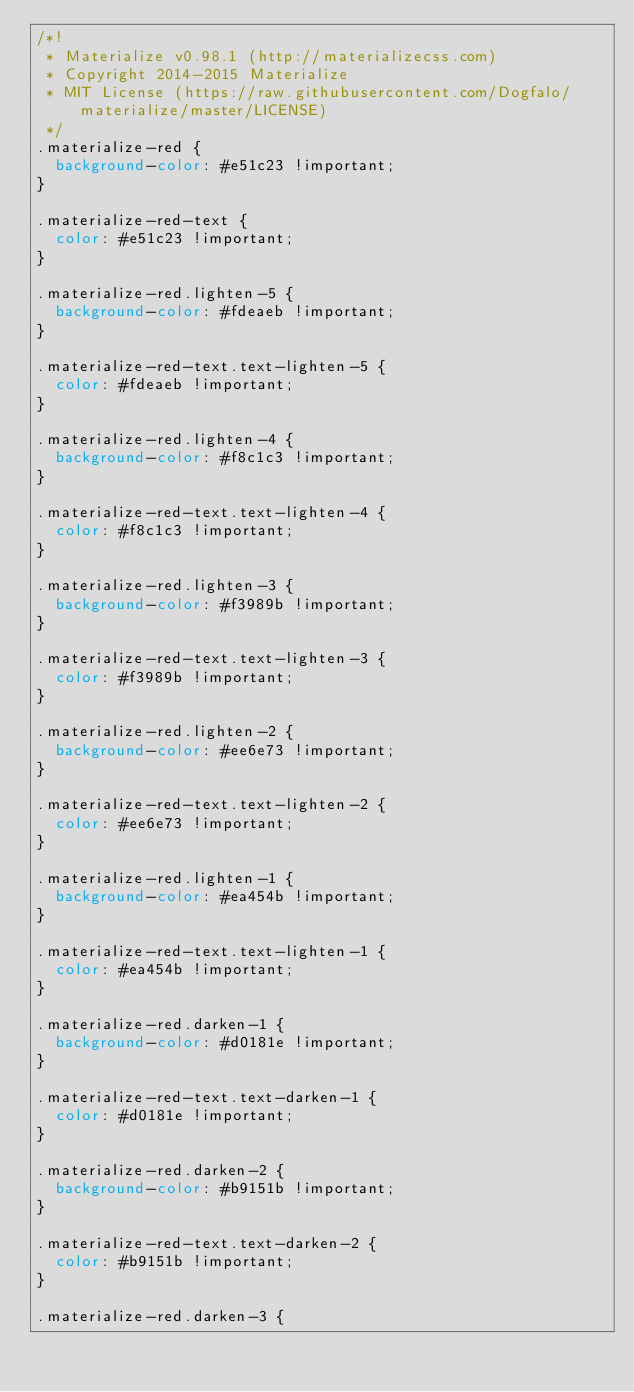Convert code to text. <code><loc_0><loc_0><loc_500><loc_500><_CSS_>/*!
 * Materialize v0.98.1 (http://materializecss.com)
 * Copyright 2014-2015 Materialize
 * MIT License (https://raw.githubusercontent.com/Dogfalo/materialize/master/LICENSE)
 */
.materialize-red {
  background-color: #e51c23 !important;
}

.materialize-red-text {
  color: #e51c23 !important;
}

.materialize-red.lighten-5 {
  background-color: #fdeaeb !important;
}

.materialize-red-text.text-lighten-5 {
  color: #fdeaeb !important;
}

.materialize-red.lighten-4 {
  background-color: #f8c1c3 !important;
}

.materialize-red-text.text-lighten-4 {
  color: #f8c1c3 !important;
}

.materialize-red.lighten-3 {
  background-color: #f3989b !important;
}

.materialize-red-text.text-lighten-3 {
  color: #f3989b !important;
}

.materialize-red.lighten-2 {
  background-color: #ee6e73 !important;
}

.materialize-red-text.text-lighten-2 {
  color: #ee6e73 !important;
}

.materialize-red.lighten-1 {
  background-color: #ea454b !important;
}

.materialize-red-text.text-lighten-1 {
  color: #ea454b !important;
}

.materialize-red.darken-1 {
  background-color: #d0181e !important;
}

.materialize-red-text.text-darken-1 {
  color: #d0181e !important;
}

.materialize-red.darken-2 {
  background-color: #b9151b !important;
}

.materialize-red-text.text-darken-2 {
  color: #b9151b !important;
}

.materialize-red.darken-3 {</code> 